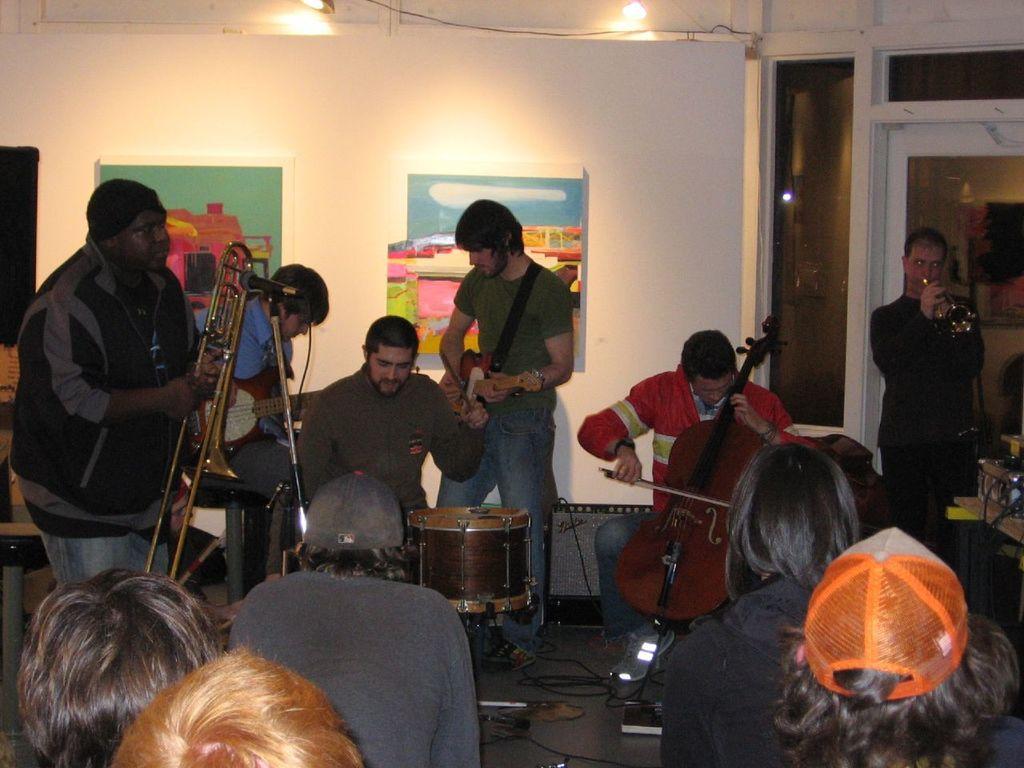Could you give a brief overview of what you see in this image? The picture is clicked in a room. There are some people playing musical instruments. The person wearing red shirt is playing violin. The person in black shirt is playing trumpet. The person in green shirt is playing guitar. The person in grey sweater is playing drums. The person in blue shirt was also playing guitar. The person in the left corner is holding a trumpet. There are another group of people who are watching them. 